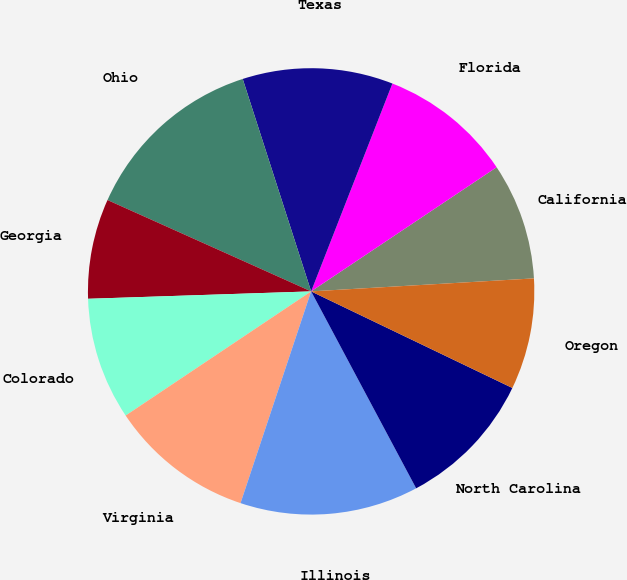<chart> <loc_0><loc_0><loc_500><loc_500><pie_chart><fcel>California<fcel>Florida<fcel>Texas<fcel>Ohio<fcel>Georgia<fcel>Colorado<fcel>Virginia<fcel>Illinois<fcel>North Carolina<fcel>Oregon<nl><fcel>8.46%<fcel>9.68%<fcel>10.89%<fcel>13.33%<fcel>7.24%<fcel>8.86%<fcel>10.49%<fcel>12.92%<fcel>10.08%<fcel>8.05%<nl></chart> 